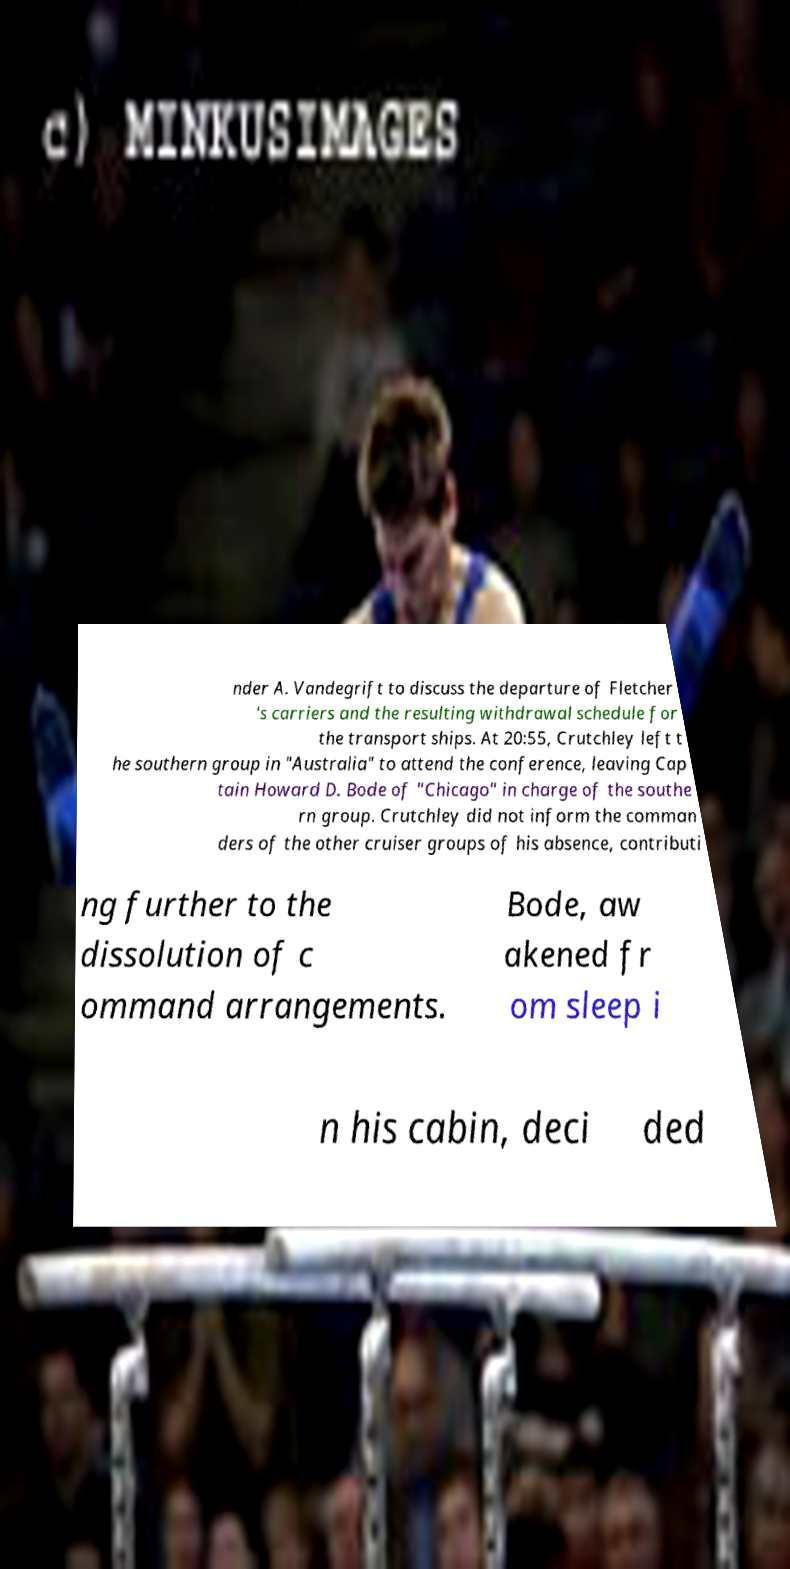What messages or text are displayed in this image? I need them in a readable, typed format. nder A. Vandegrift to discuss the departure of Fletcher 's carriers and the resulting withdrawal schedule for the transport ships. At 20:55, Crutchley left t he southern group in "Australia" to attend the conference, leaving Cap tain Howard D. Bode of "Chicago" in charge of the southe rn group. Crutchley did not inform the comman ders of the other cruiser groups of his absence, contributi ng further to the dissolution of c ommand arrangements. Bode, aw akened fr om sleep i n his cabin, deci ded 